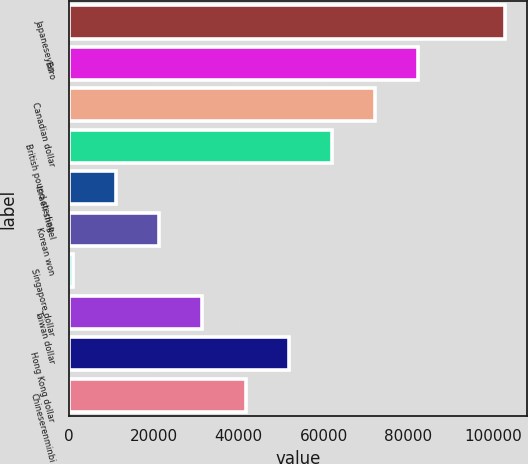Convert chart. <chart><loc_0><loc_0><loc_500><loc_500><bar_chart><fcel>Japaneseyen<fcel>Euro<fcel>Canadian dollar<fcel>British pound sterling<fcel>Israeli shekel<fcel>Korean won<fcel>Singapore dollar<fcel>Taiwan dollar<fcel>Hong Kong dollar<fcel>Chineserenminbi<nl><fcel>102678<fcel>82329.6<fcel>72155.4<fcel>61981.2<fcel>11110.2<fcel>21284.4<fcel>936<fcel>31458.6<fcel>51807<fcel>41632.8<nl></chart> 